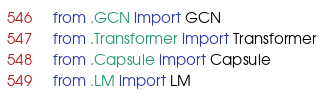<code> <loc_0><loc_0><loc_500><loc_500><_Python_>from .GCN import GCN
from .Transformer import Transformer
from .Capsule import Capsule
from .LM import LM
</code> 